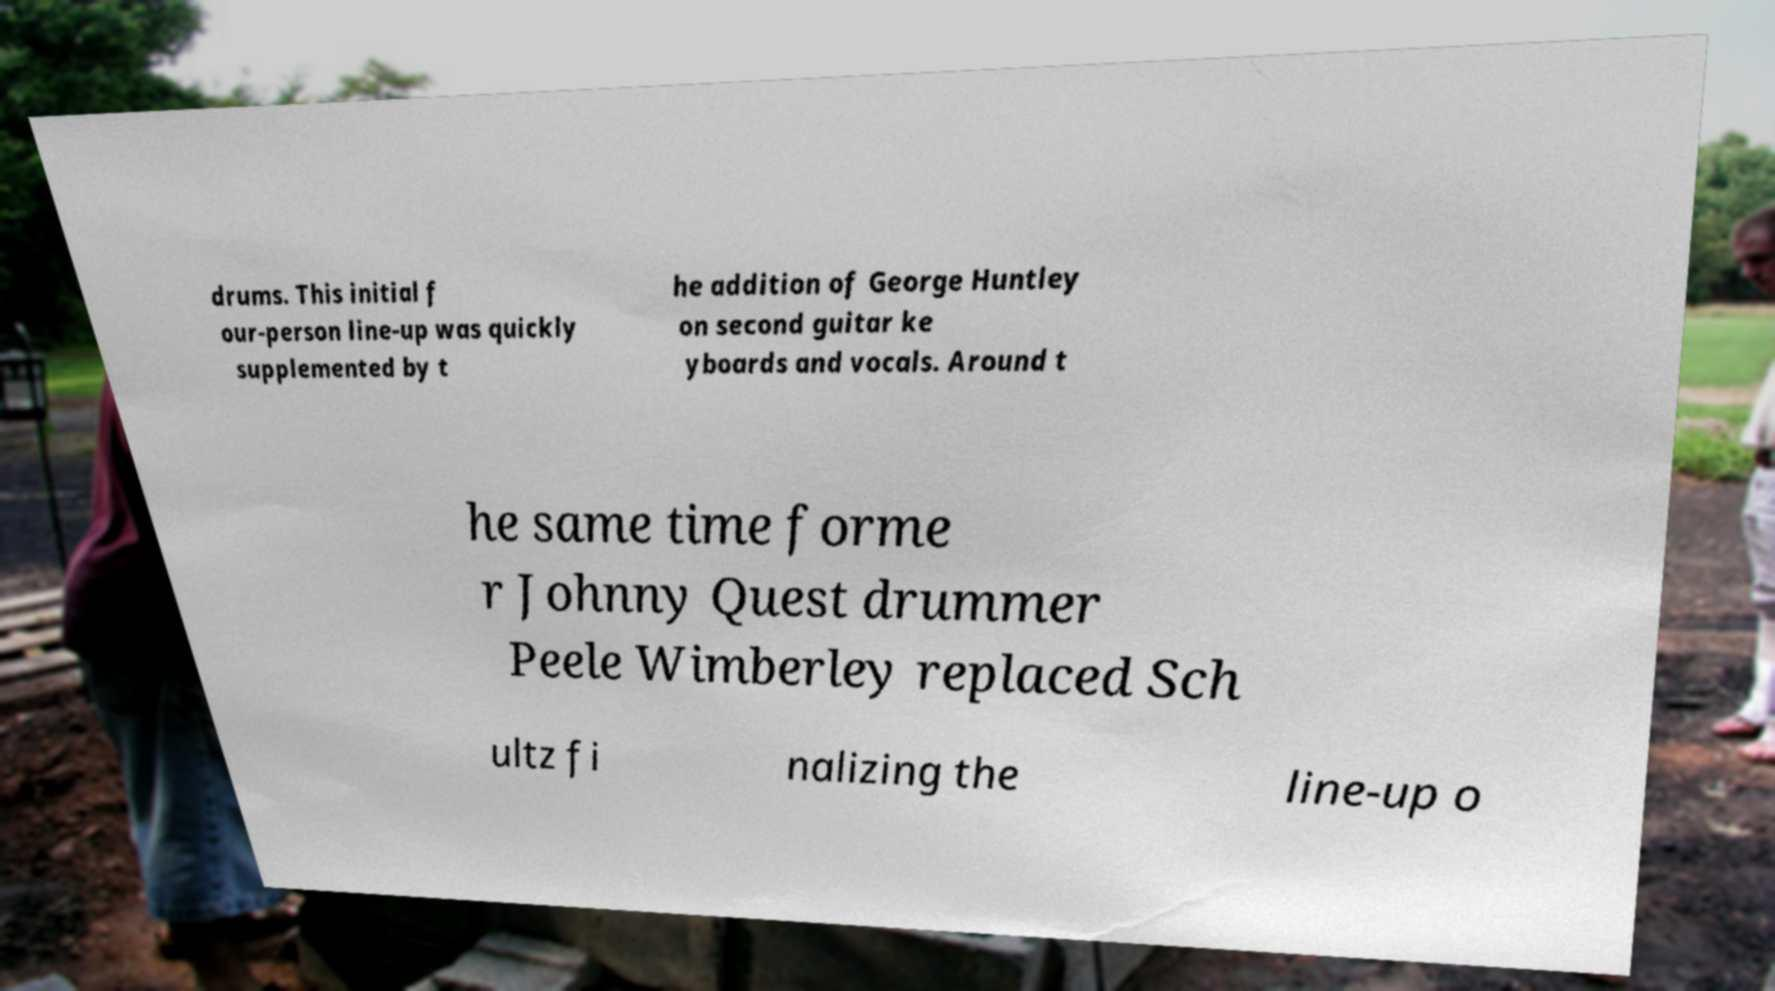Could you assist in decoding the text presented in this image and type it out clearly? drums. This initial f our-person line-up was quickly supplemented by t he addition of George Huntley on second guitar ke yboards and vocals. Around t he same time forme r Johnny Quest drummer Peele Wimberley replaced Sch ultz fi nalizing the line-up o 